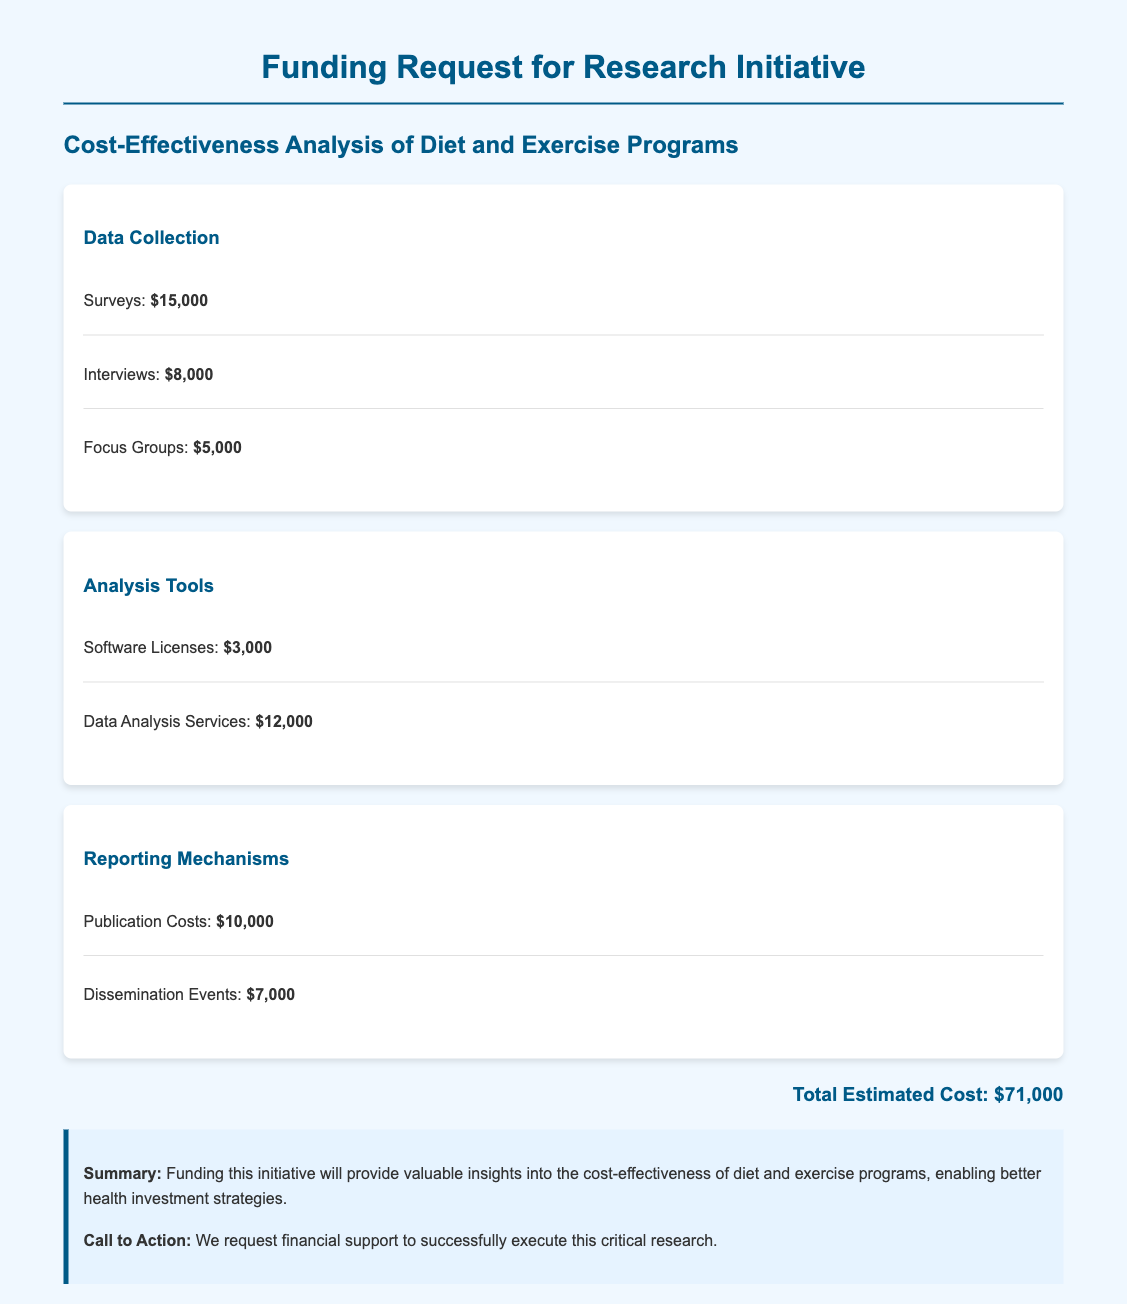What is the total estimated cost? The total estimated cost is summarized at the bottom of the document, which includes all the budgeted items.
Answer: $71,000 How much is allocated for surveys? The budget section for data collection lists the amount specifically allocated for surveys.
Answer: $15,000 What is the cost of data analysis services? The analysis tools section mentions the specific cost for data analysis services.
Answer: $12,000 What are the costs for dissemination events? The reporting mechanisms section provides the specific cost allocated for dissemination events.
Answer: $7,000 What is the total amount allocated for focus groups? The budget for data collection includes a separate line for focus groups to determine its cost.
Answer: $5,000 How much is budgeted for publication costs? The reporting mechanisms section details the budgeted amount for publication costs.
Answer: $10,000 Which area has the highest expense in data collection? The data collection section allows us to compare costs and identify the item with the highest expense.
Answer: Surveys What is the main purpose of this funding request? The conclusion summarizes the intended outcome and significance of funding regarding health investment strategies.
Answer: Cost-effectiveness analysis What type of research does the initiative focus on? The title and description of the document highlight the specific subject of the research initiative.
Answer: Diet and exercise programs 